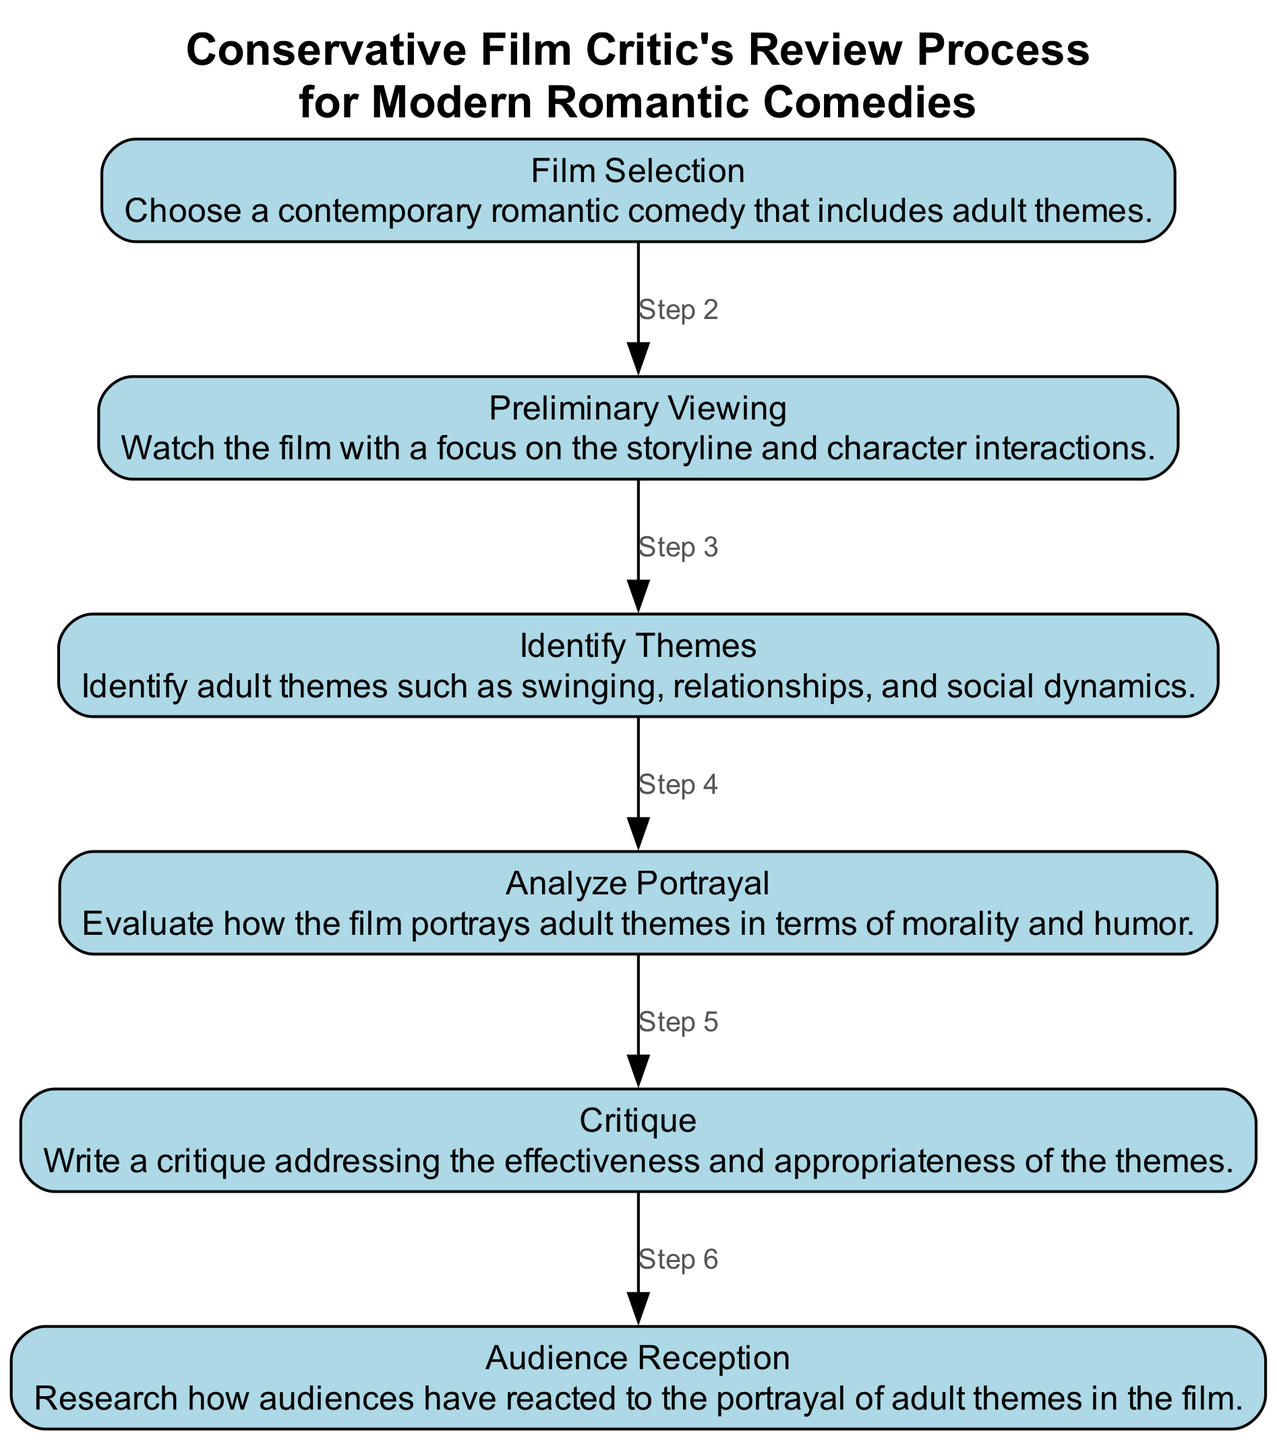What is the first step in the review process? The first step in the review process, as indicated in the diagram, is "Film Selection," where a contemporary romantic comedy that includes adult themes is chosen.
Answer: Film Selection How many steps are there in the review process? By counting the elements represented in the diagram, there are a total of six distinct steps in the film review process.
Answer: 6 What follows "Preliminary Viewing" in the sequence? The step that immediately follows "Preliminary Viewing" is "Identify Themes," indicating that after watching the film, the next action is to identify specific adult themes present.
Answer: Identify Themes Which step focuses on audience reactions? The step that deals with audience reactions is "Audience Reception," where the reactions to the portrayal of adult themes in the film are researched.
Answer: Audience Reception What is the relationship between "Identify Themes" and "Analyze Portrayal"? The relationship is sequential, as "Analyze Portrayal" follows "Identify Themes," demonstrating that after identifying adult themes, the next action is to analyze how those themes are portrayed in the film.
Answer: Sequential What two themes are mentioned in the "Identify Themes" step? In the "Identify Themes" step, two themes that are mentioned are "swinging" and "relationships," showcasing specific adult themes that may be present in the film.
Answer: swinging, relationships Which step involves writing a critique? The step in the process that involves writing a critique is simply called "Critique," where the effectiveness and appropriateness of the identified themes are addressed in a written format.
Answer: Critique How does the review process end? The review process concludes with the "Audience Reception" step, as it is the last element listed in the sequence, indicating that audience reactions are the final consideration in the review process.
Answer: Audience Reception What type of themes are being analyzed in "Analyze Portrayal"? The themes being analyzed in "Analyze Portrayal" are adult themes, specifically regarding their portrayal in terms of morality and humor.
Answer: adult themes 